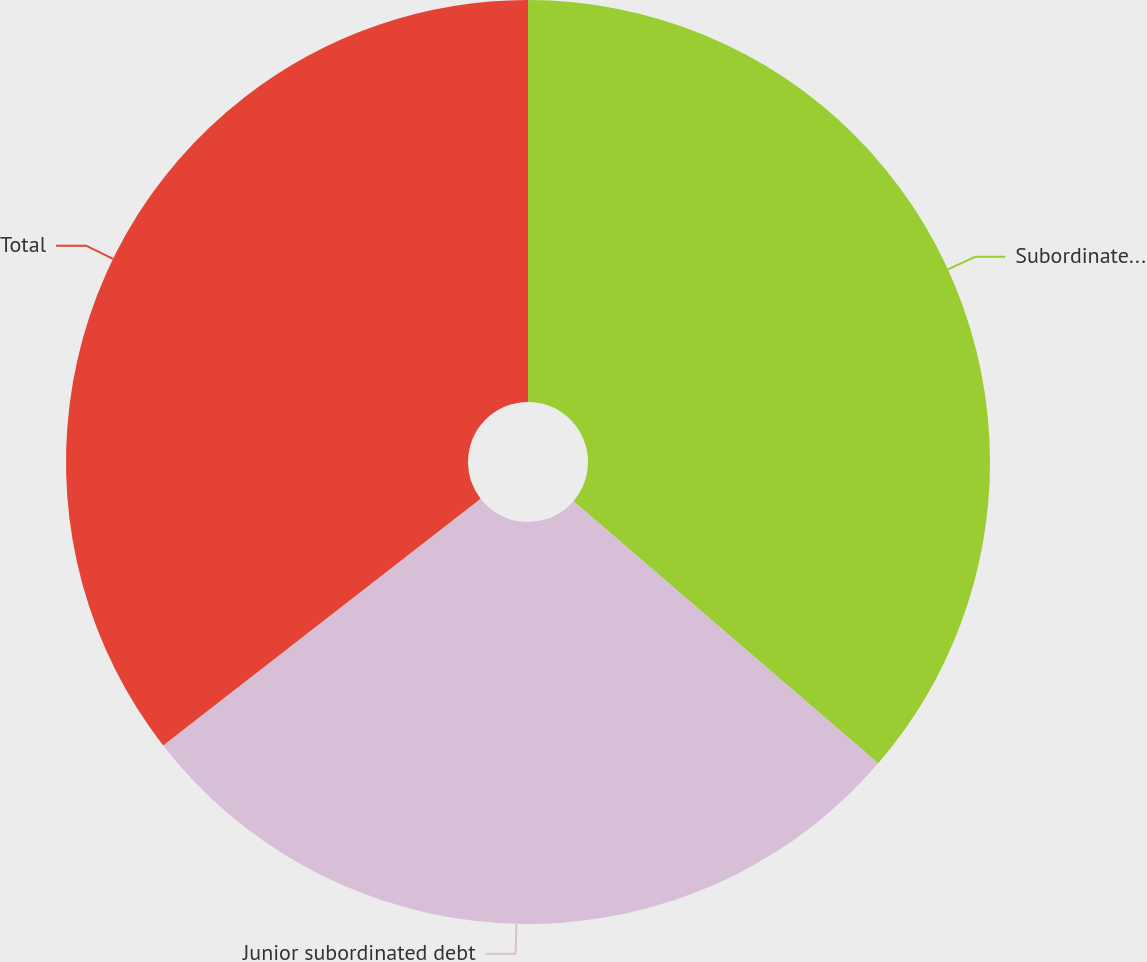Convert chart. <chart><loc_0><loc_0><loc_500><loc_500><pie_chart><fcel>Subordinated debt<fcel>Junior subordinated debt<fcel>Total<nl><fcel>36.31%<fcel>28.18%<fcel>35.51%<nl></chart> 